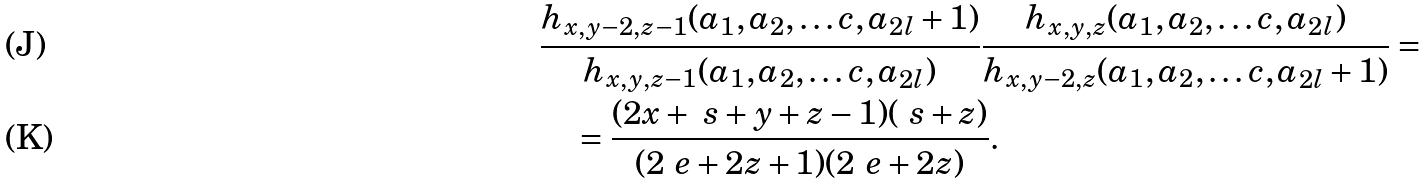<formula> <loc_0><loc_0><loc_500><loc_500>& \frac { h _ { x , y - 2 , z - 1 } ( a _ { 1 } , a _ { 2 } , \dots c , a _ { 2 l } + 1 ) } { h _ { x , y , z - 1 } ( a _ { 1 } , a _ { 2 } , \dots c , a _ { 2 l } ) } \frac { h _ { x , y , z } ( a _ { 1 } , a _ { 2 } , \dots c , a _ { 2 l } ) } { h _ { x , y - 2 , z } ( a _ { 1 } , a _ { 2 } , \dots c , a _ { 2 l } + 1 ) } = \\ & \quad = \frac { ( 2 x + \ s + y + z - 1 ) ( \ s + z ) } { ( 2 \ e + 2 z + 1 ) ( 2 \ e + 2 z ) } .</formula> 